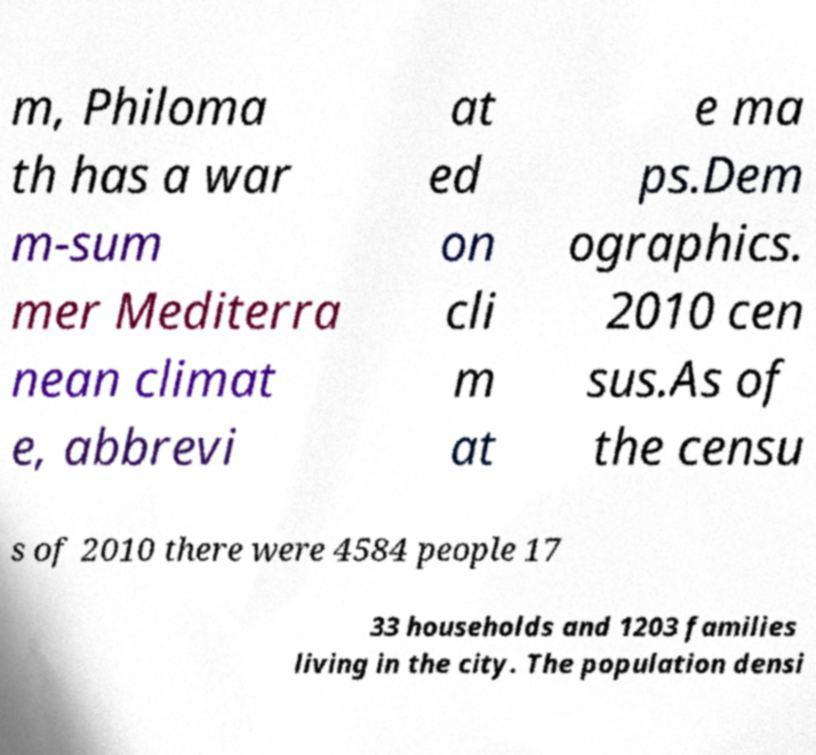For documentation purposes, I need the text within this image transcribed. Could you provide that? m, Philoma th has a war m-sum mer Mediterra nean climat e, abbrevi at ed on cli m at e ma ps.Dem ographics. 2010 cen sus.As of the censu s of 2010 there were 4584 people 17 33 households and 1203 families living in the city. The population densi 